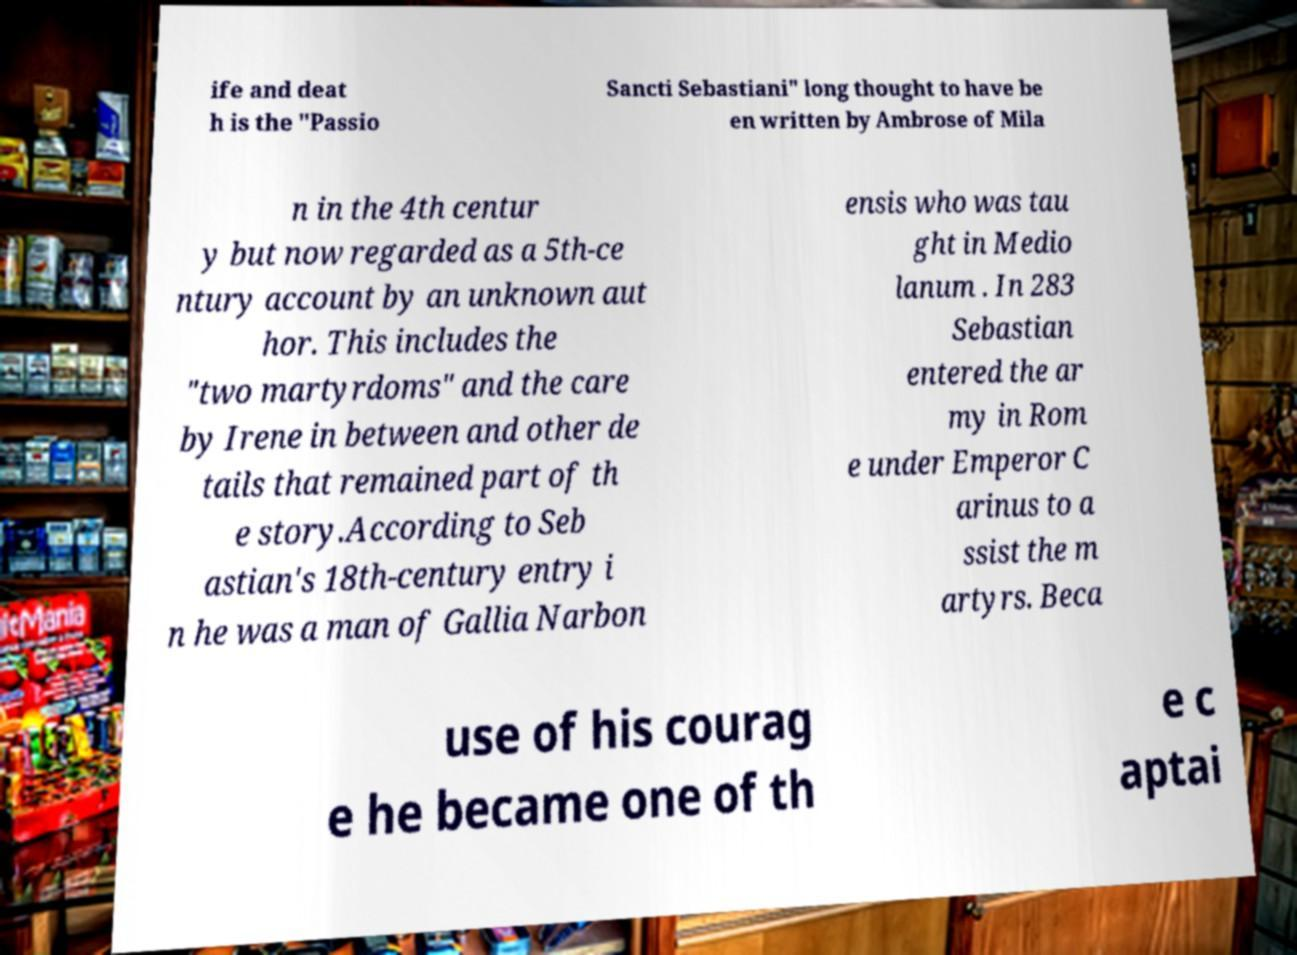What messages or text are displayed in this image? I need them in a readable, typed format. ife and deat h is the "Passio Sancti Sebastiani" long thought to have be en written by Ambrose of Mila n in the 4th centur y but now regarded as a 5th-ce ntury account by an unknown aut hor. This includes the "two martyrdoms" and the care by Irene in between and other de tails that remained part of th e story.According to Seb astian's 18th-century entry i n he was a man of Gallia Narbon ensis who was tau ght in Medio lanum . In 283 Sebastian entered the ar my in Rom e under Emperor C arinus to a ssist the m artyrs. Beca use of his courag e he became one of th e c aptai 